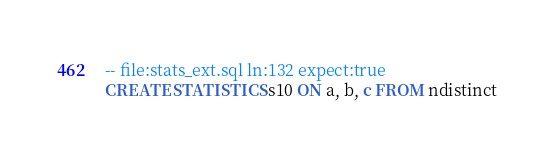<code> <loc_0><loc_0><loc_500><loc_500><_SQL_>-- file:stats_ext.sql ln:132 expect:true
CREATE STATISTICS s10 ON a, b, c FROM ndistinct
</code> 